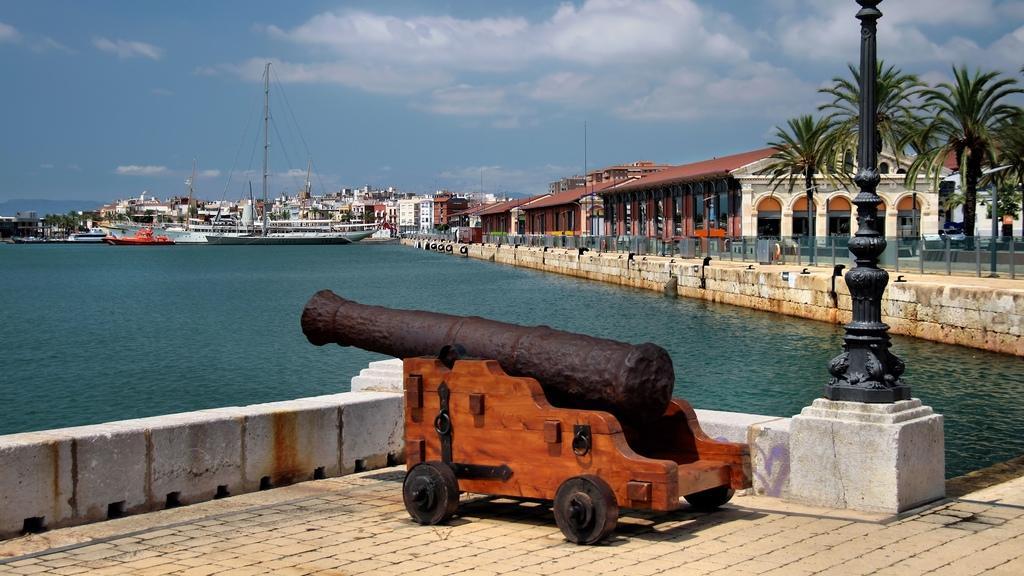How would you summarize this image in a sentence or two? In this picture we can see a cannon, water, boats, buildings, trees, fence, poles and in the background we can see the sky with clouds. 